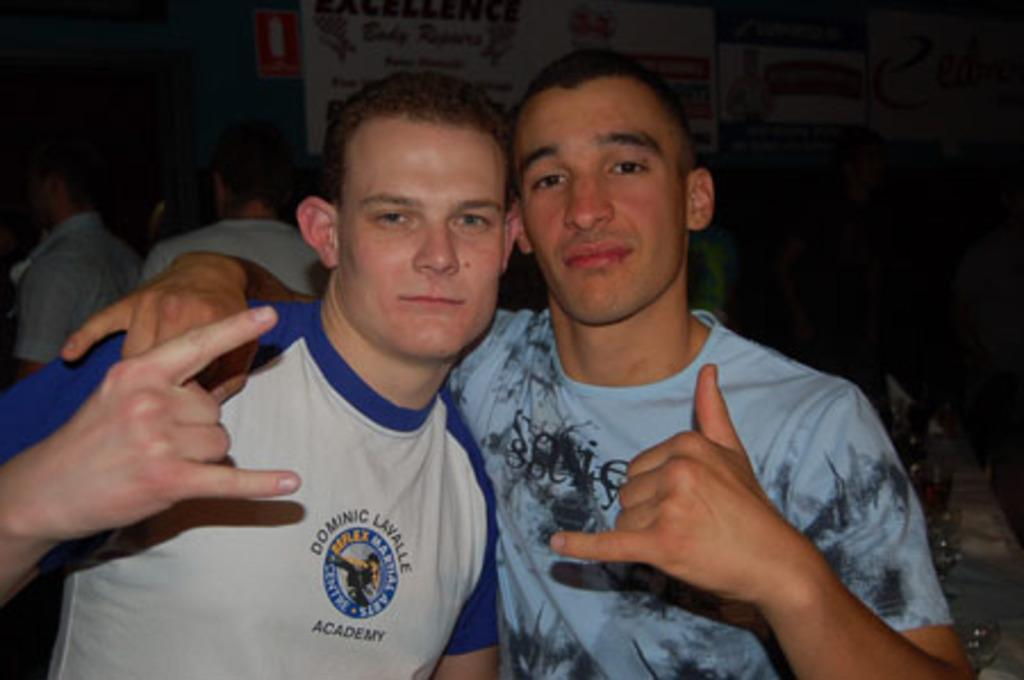How many people are in the image? There are two men in the image. What are the two men doing in the image? The two men are posing for a photograph. Can you describe the background of the image? There are people in the background of the image. What type of iron can be seen in the image? There is no iron present in the image. How many pigs are visible in the image? There are no pigs visible in the image. 